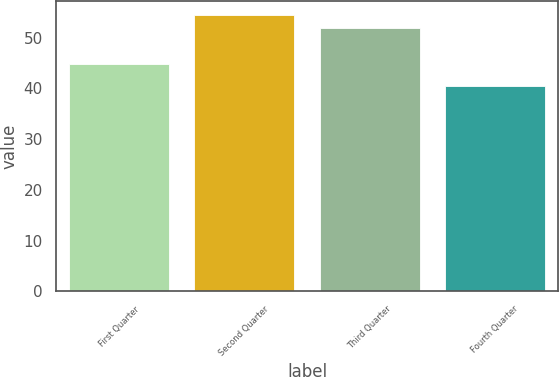Convert chart to OTSL. <chart><loc_0><loc_0><loc_500><loc_500><bar_chart><fcel>First Quarter<fcel>Second Quarter<fcel>Third Quarter<fcel>Fourth Quarter<nl><fcel>44.87<fcel>54.57<fcel>51.99<fcel>40.5<nl></chart> 